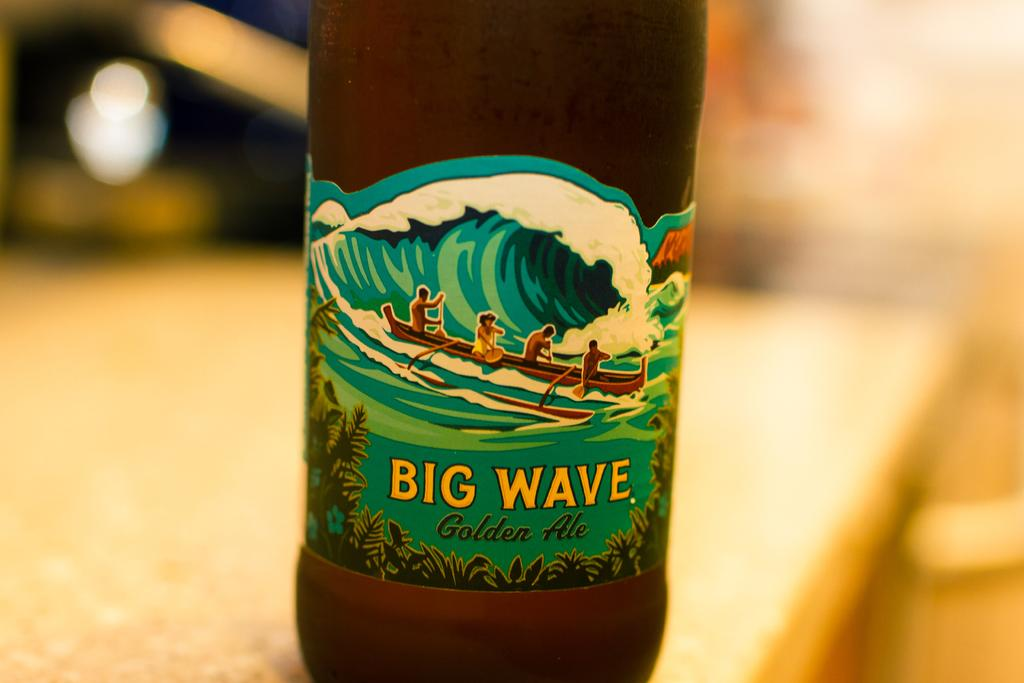<image>
Summarize the visual content of the image. A bottle of Big Wave golden ale is on a table. 